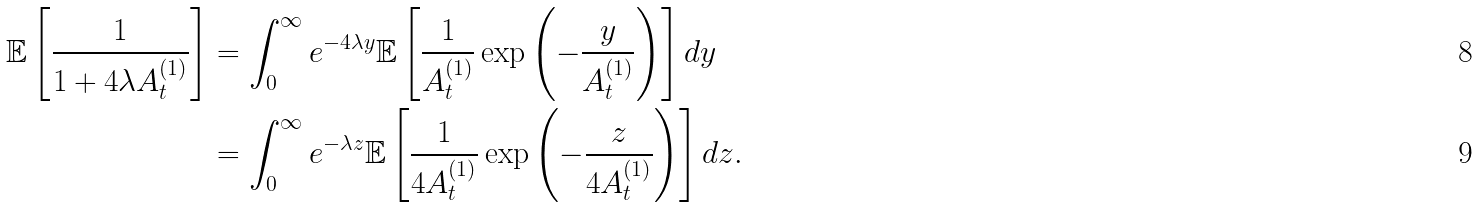Convert formula to latex. <formula><loc_0><loc_0><loc_500><loc_500>\mathbb { E } \left [ \frac { 1 } { 1 + 4 \lambda A _ { t } ^ { ( 1 ) } } \right ] & = \int _ { 0 } ^ { \infty } e ^ { - 4 \lambda y } \mathbb { E } \left [ \frac { 1 } { A _ { t } ^ { ( 1 ) } } \exp \left ( - \frac { y } { A _ { t } ^ { ( 1 ) } } \right ) \right ] d y \\ & = \int _ { 0 } ^ { \infty } e ^ { - \lambda z } \mathbb { E } \left [ \frac { 1 } { 4 A _ { t } ^ { ( 1 ) } } \exp \left ( - \frac { z } { 4 A _ { t } ^ { ( 1 ) } } \right ) \right ] d z .</formula> 